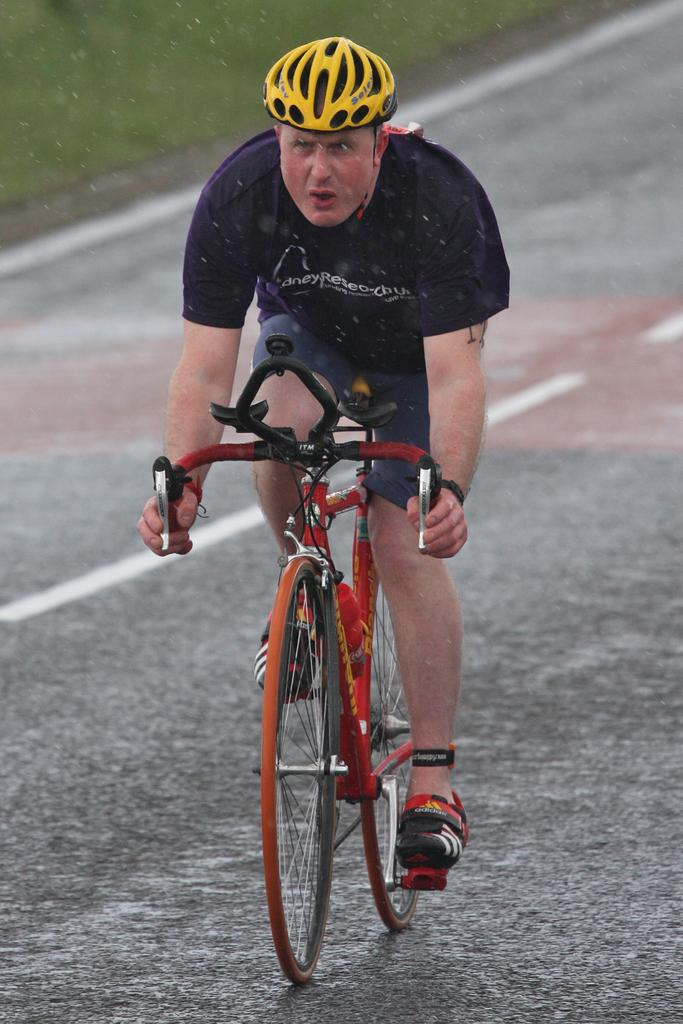Who or what is the main subject in the image? There is a person in the image. What is the person doing in the image? The person is riding a bicycle. Where is the person located in the image? The person is on the road. What safety precaution is the person taking in the image? The person is wearing a helmet. What type of bag is the carpenter using to carry their tools in the image? There is no carpenter or bag present in the image; it features a person riding a bicycle on the road. 